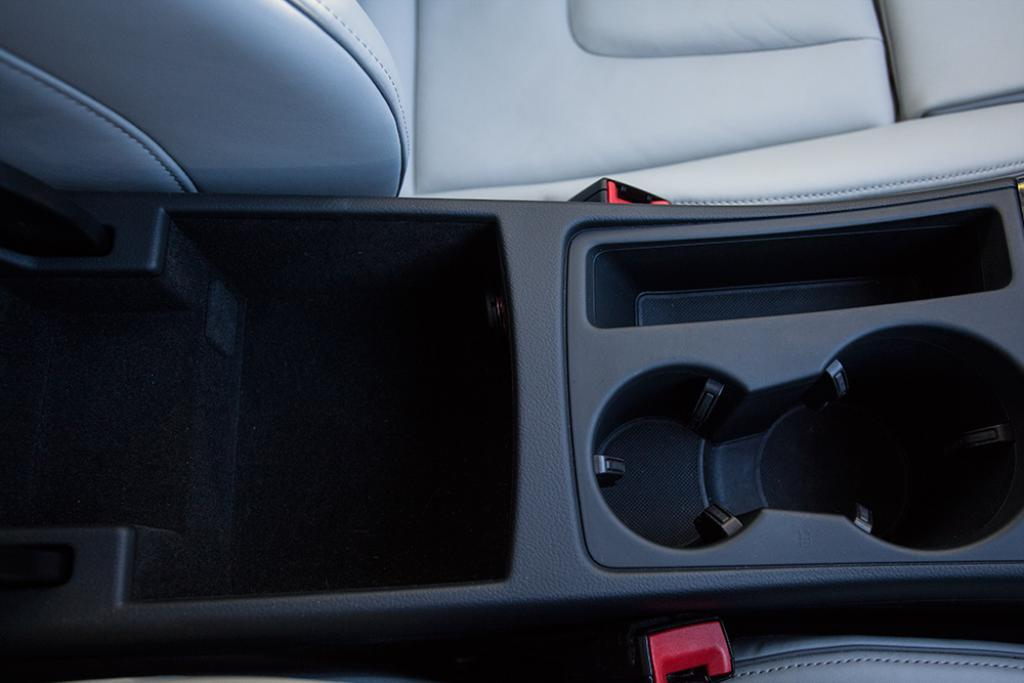What type of setting is depicted in the image? The image shows an inside view of a vehicle. What can be seen inside the vehicle? There is a seat visible in the image. What safety feature is present in the image? There is a belt holder in the image. What type of haircut does the driver have in the image? There is no driver visible in the image, so it is not possible to determine the driver's haircut. 